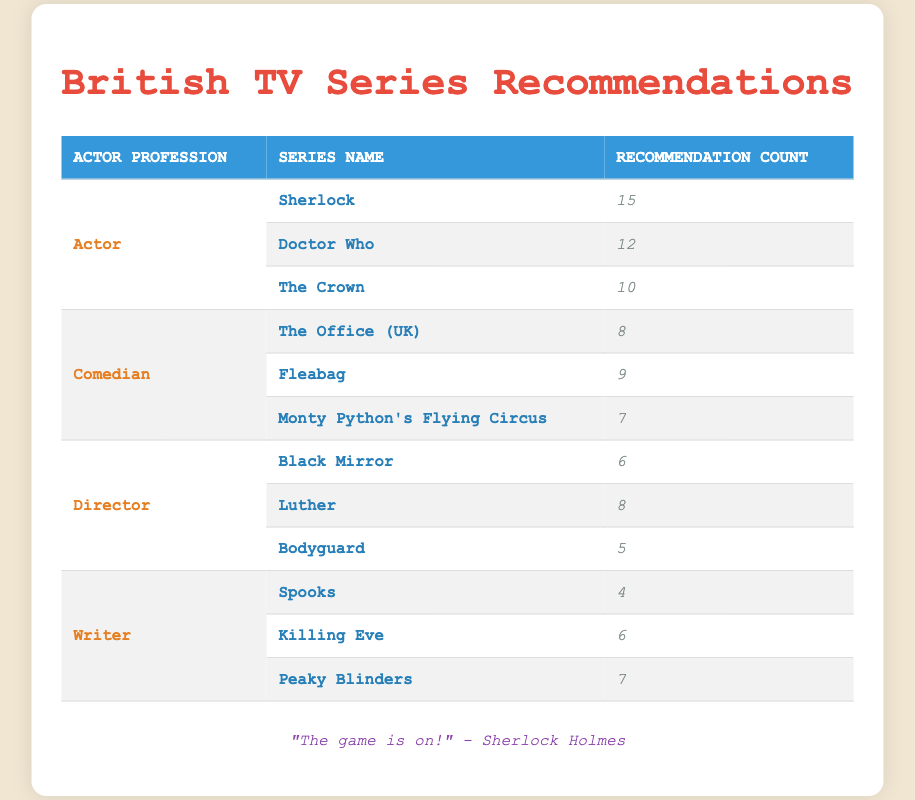What is the most recommended series by Actors? The table shows that "Sherlock" has the highest recommendation count among actors, with a total of 15 recommendations.
Answer: Sherlock Which series did Comedians recommend the most? According to the table, "Fleabag" received the highest number of recommendations from comedians, totaling 9.
Answer: Fleabag True or False: "The Crown" received more recommendations than any series recommended by Directors. "The Crown" has 10 recommendations, while the highest recommendation for Directors is 8 for "Luther." Therefore, the statement is true.
Answer: True What is the total recommendation count for series recommended by Writers? By adding the recommendation counts (4 for "Spooks," 6 for "Killing Eve," and 7 for "Peaky Blinders"), the total is 4 + 6 + 7 = 17.
Answer: 17 Which profession recommended the least number of unique series? The Directors recommended 3 unique series: "Black Mirror," "Luther," and "Bodyguard." Other professions also recommended 3 unique series, but the counts are lower compared to others. Comparing the recommendation counts shows that the total for Directors is less than the total for both Actors and Writers but not for Comedians (as their total count does not affect series count). Therefore, it's Directors who recommended fewer series.
Answer: Directors What is the difference between the highest recommendation count from Actors and the highest from Comedians? The highest recommendation count from Actors is 15 for "Sherlock," and the highest from Comedians is 9 for "Fleabag." The difference is 15 - 9 = 6.
Answer: 6 True or False: "Monty Python's Flying Circus" received more recommendations than "Bodyguard." "Monty Python's Flying Circus" has 7 recommendations, while "Bodyguard" has 5, making the statement true.
Answer: True Which series titles were recommended by Writers and had a total recommendation count of less than 10? The series titles "Spooks" and "Killing Eve" each received 4 and 6 recommendations respectively, both are less than 10. "Peaky Blinders" received 7 recommendations, which also qualifies under this criterion. Therefore, all three series are correct.
Answer: Spooks, Killing Eve, Peaky Blinders What is the average recommendation count for each profession? The average can be calculated by adding the total recommendations for each profession and dividing by the number of series they recommended. For Actors: (15+12+10) / 3 = 12.33; For Comedians: (8+9+7) / 3 = 8; For Directors: (6+8+5) / 3 = 6.33; For Writers: (4+6+7) / 3 = 5.67. Therefore, average for Actors is 12.33, Comedians is 8, Directors is 6.33, and Writers is 5.67.
Answer: Actors: 12.33, Comedians: 8, Directors: 6.33, Writers: 5.67 